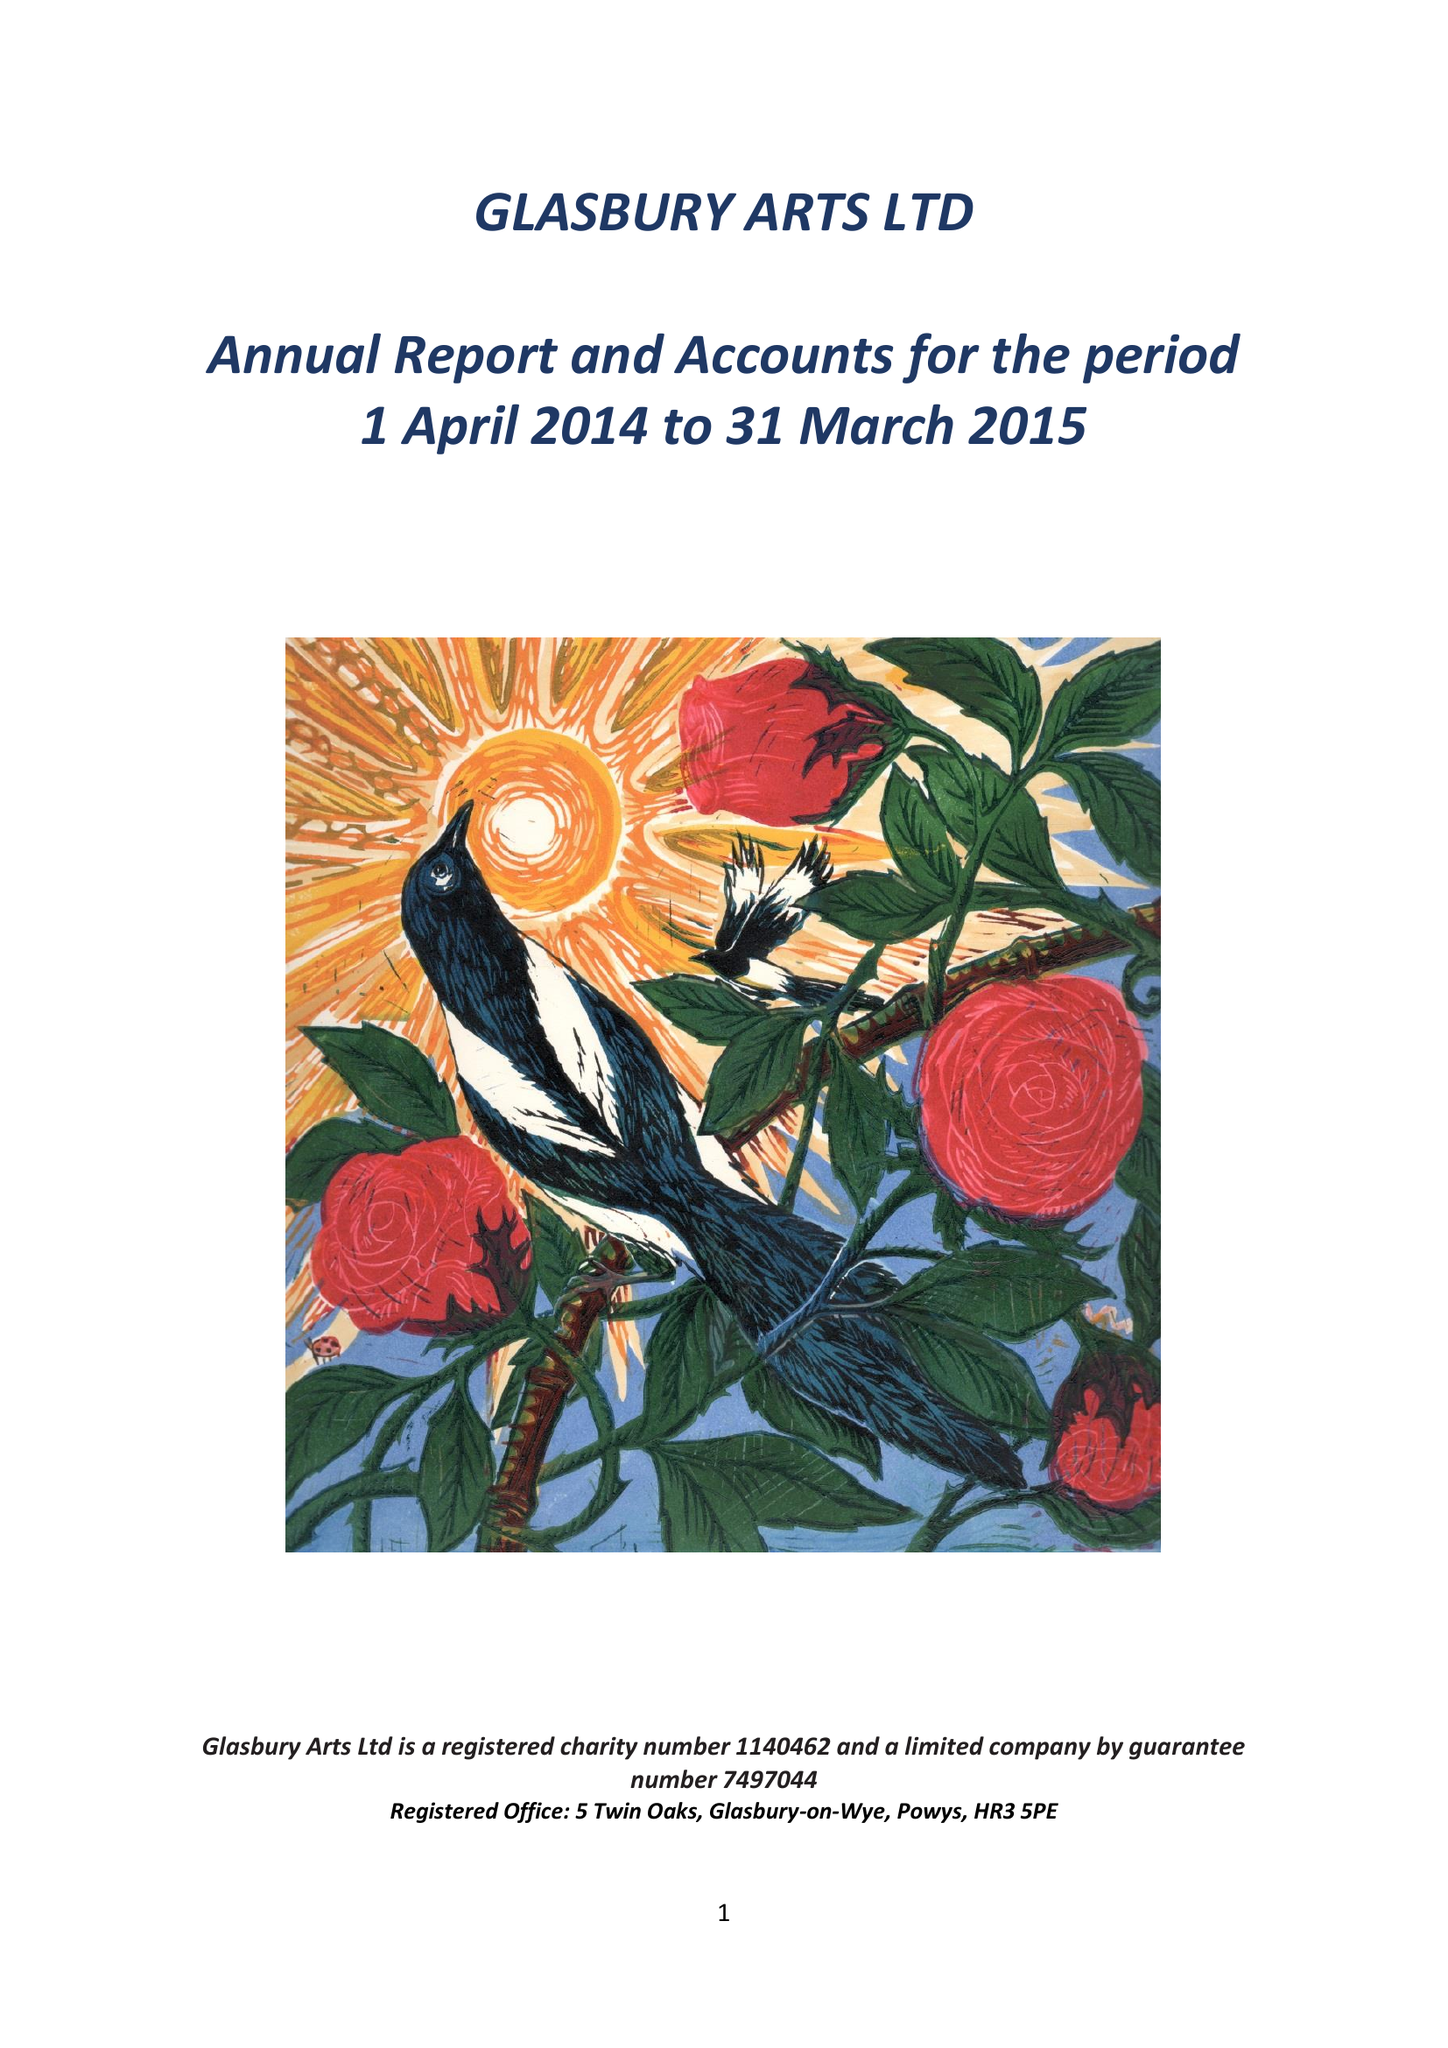What is the value for the charity_name?
Answer the question using a single word or phrase. Glasbury Arts Ltd. 